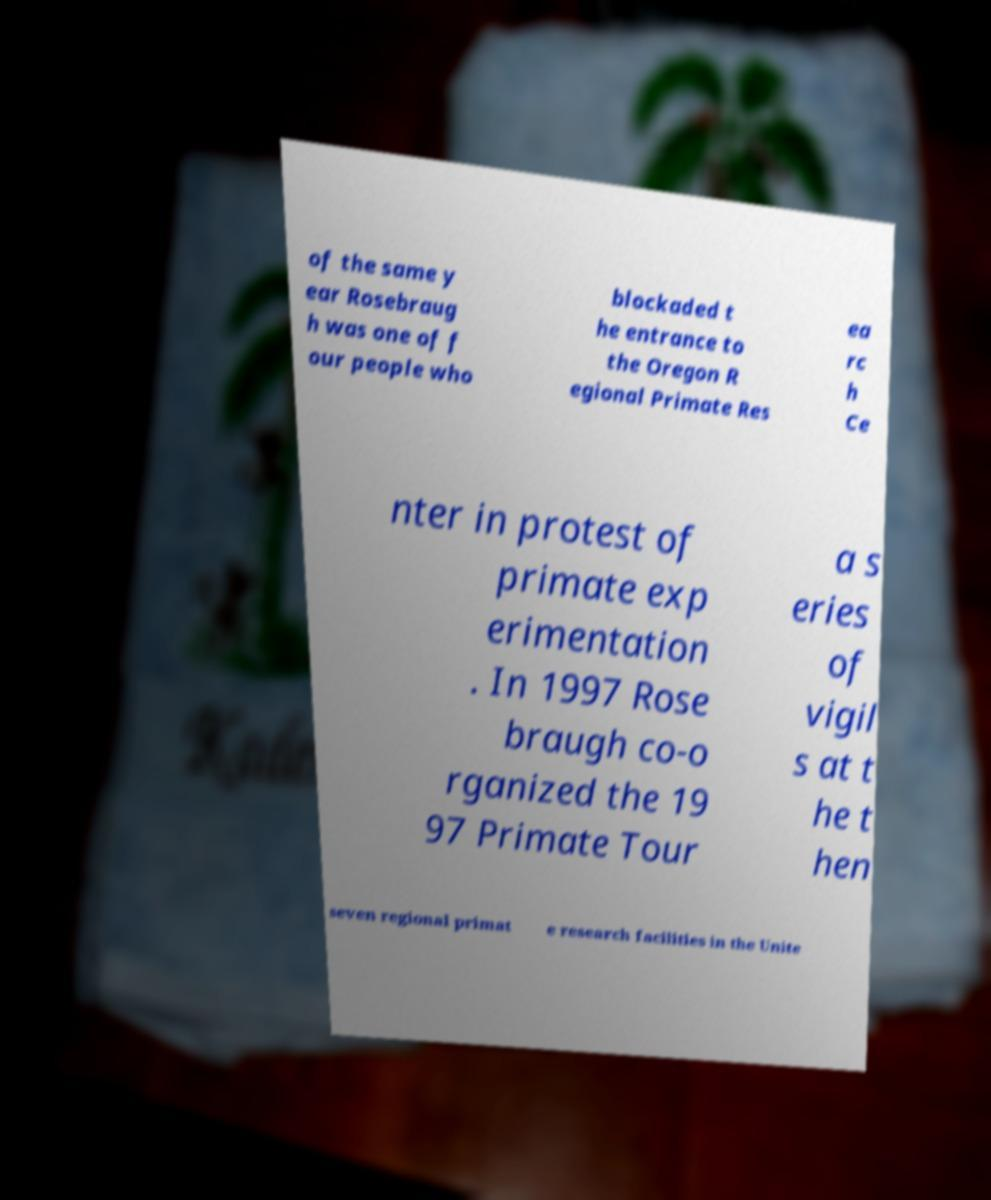Can you accurately transcribe the text from the provided image for me? of the same y ear Rosebraug h was one of f our people who blockaded t he entrance to the Oregon R egional Primate Res ea rc h Ce nter in protest of primate exp erimentation . In 1997 Rose braugh co-o rganized the 19 97 Primate Tour a s eries of vigil s at t he t hen seven regional primat e research facilities in the Unite 